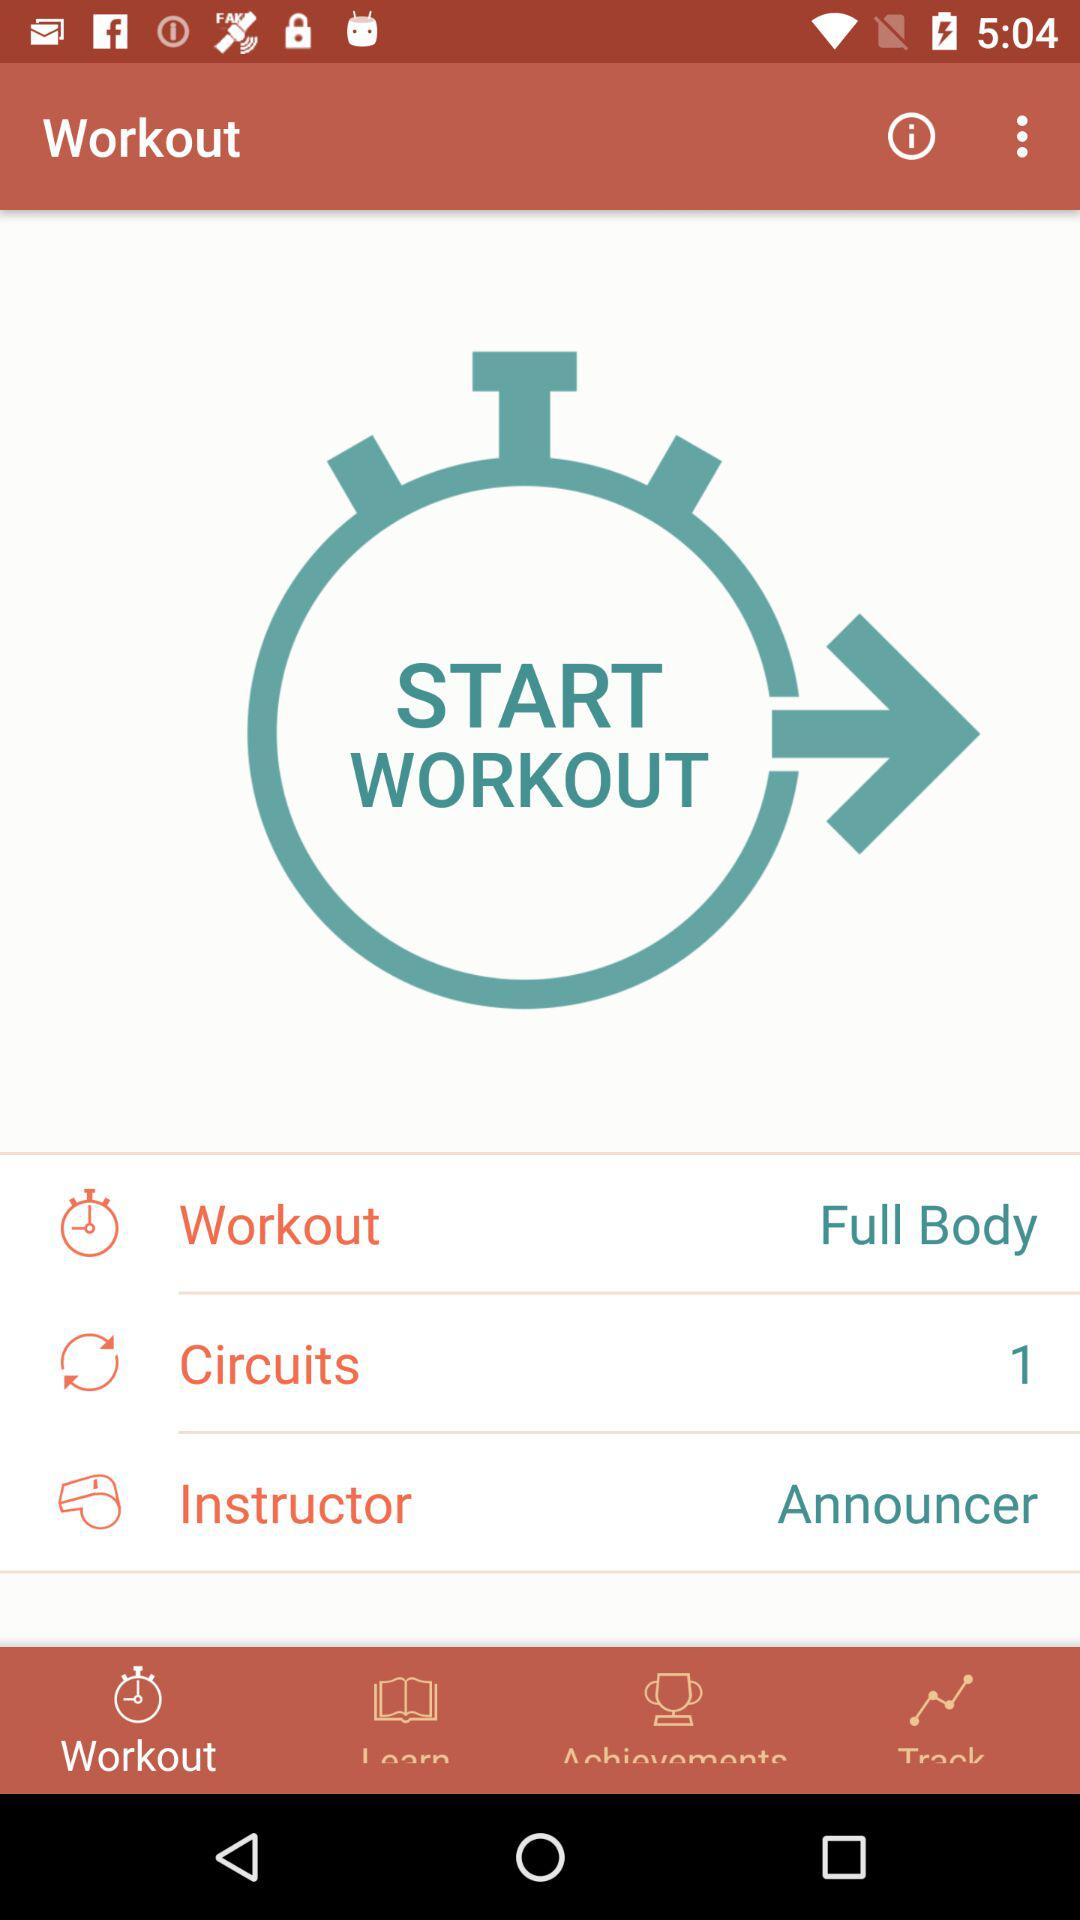Who is the instructor? The instructor is "Announcer". 